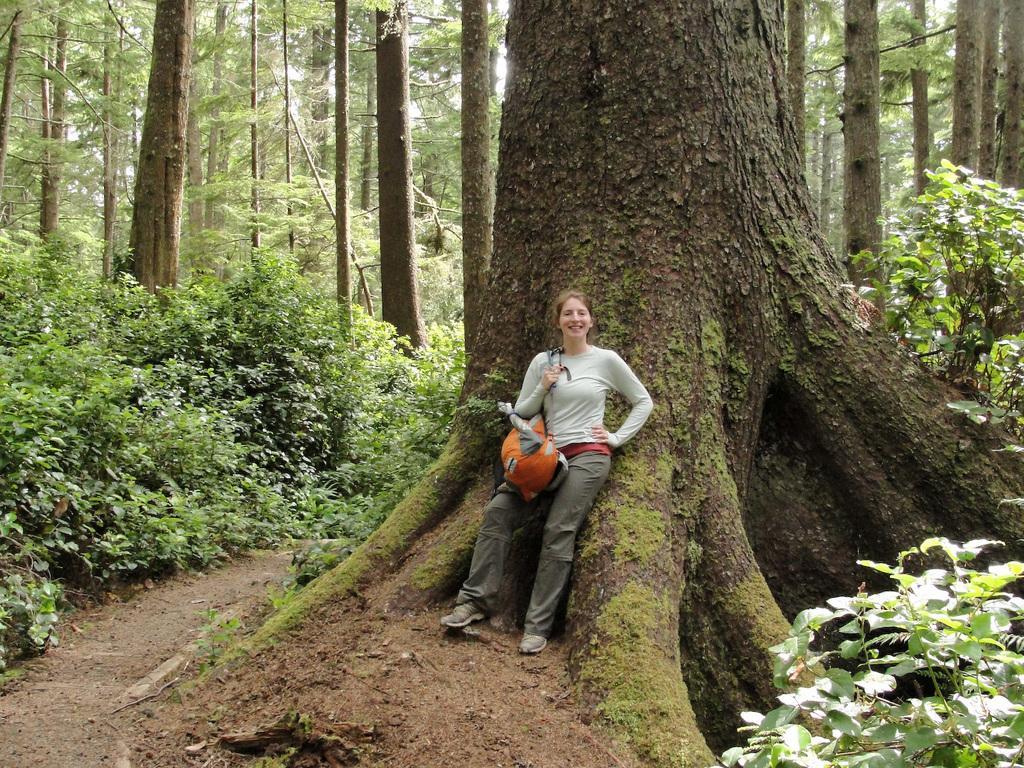Could you give a brief overview of what you see in this image? It seems to be a forest. In the middle of the image there is a woman wearing a bag, smiling and giving pose for the picture. At the back of her there is a tree trunk. On the left side there are few plants. In the background there are many trees. 